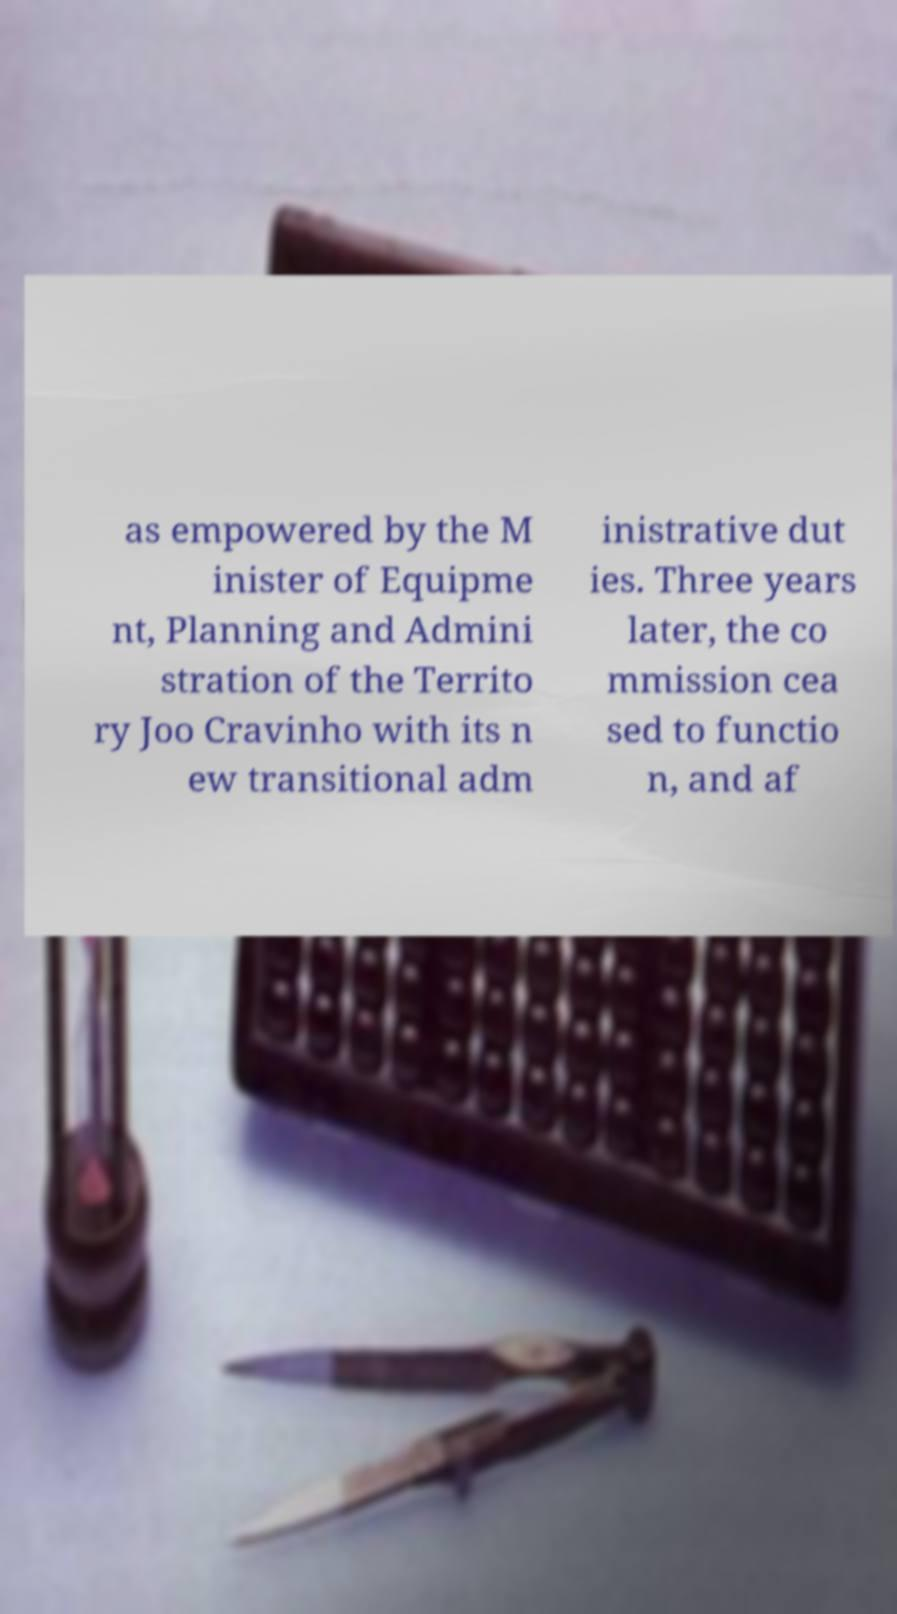Can you read and provide the text displayed in the image?This photo seems to have some interesting text. Can you extract and type it out for me? as empowered by the M inister of Equipme nt, Planning and Admini stration of the Territo ry Joo Cravinho with its n ew transitional adm inistrative dut ies. Three years later, the co mmission cea sed to functio n, and af 